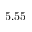Convert formula to latex. <formula><loc_0><loc_0><loc_500><loc_500>5 . 5 5</formula> 